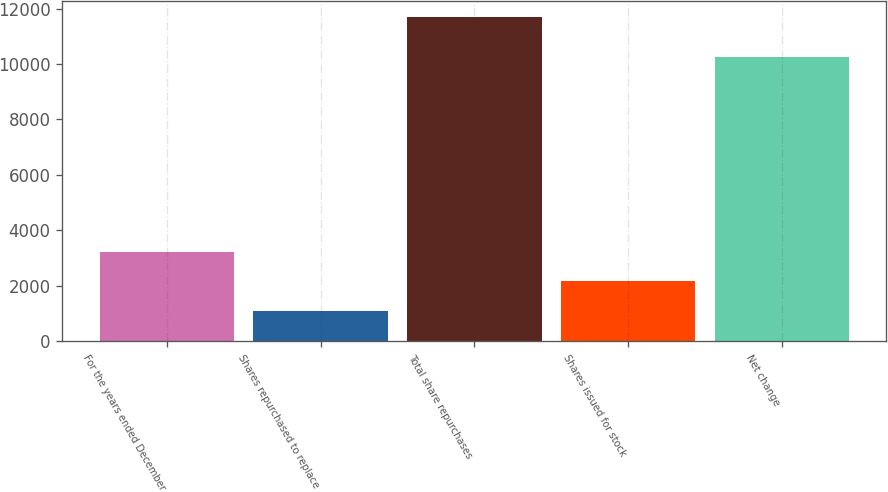Convert chart to OTSL. <chart><loc_0><loc_0><loc_500><loc_500><bar_chart><fcel>For the years ended December<fcel>Shares repurchased to replace<fcel>Total share repurchases<fcel>Shares issued for stock<fcel>Net change<nl><fcel>3216.2<fcel>1096<fcel>11697<fcel>2156.1<fcel>10260<nl></chart> 